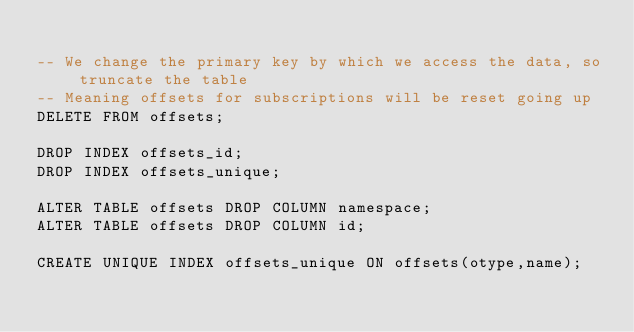<code> <loc_0><loc_0><loc_500><loc_500><_SQL_>
-- We change the primary key by which we access the data, so truncate the table
-- Meaning offsets for subscriptions will be reset going up
DELETE FROM offsets;

DROP INDEX offsets_id;
DROP INDEX offsets_unique;

ALTER TABLE offsets DROP COLUMN namespace;
ALTER TABLE offsets DROP COLUMN id;

CREATE UNIQUE INDEX offsets_unique ON offsets(otype,name);
</code> 